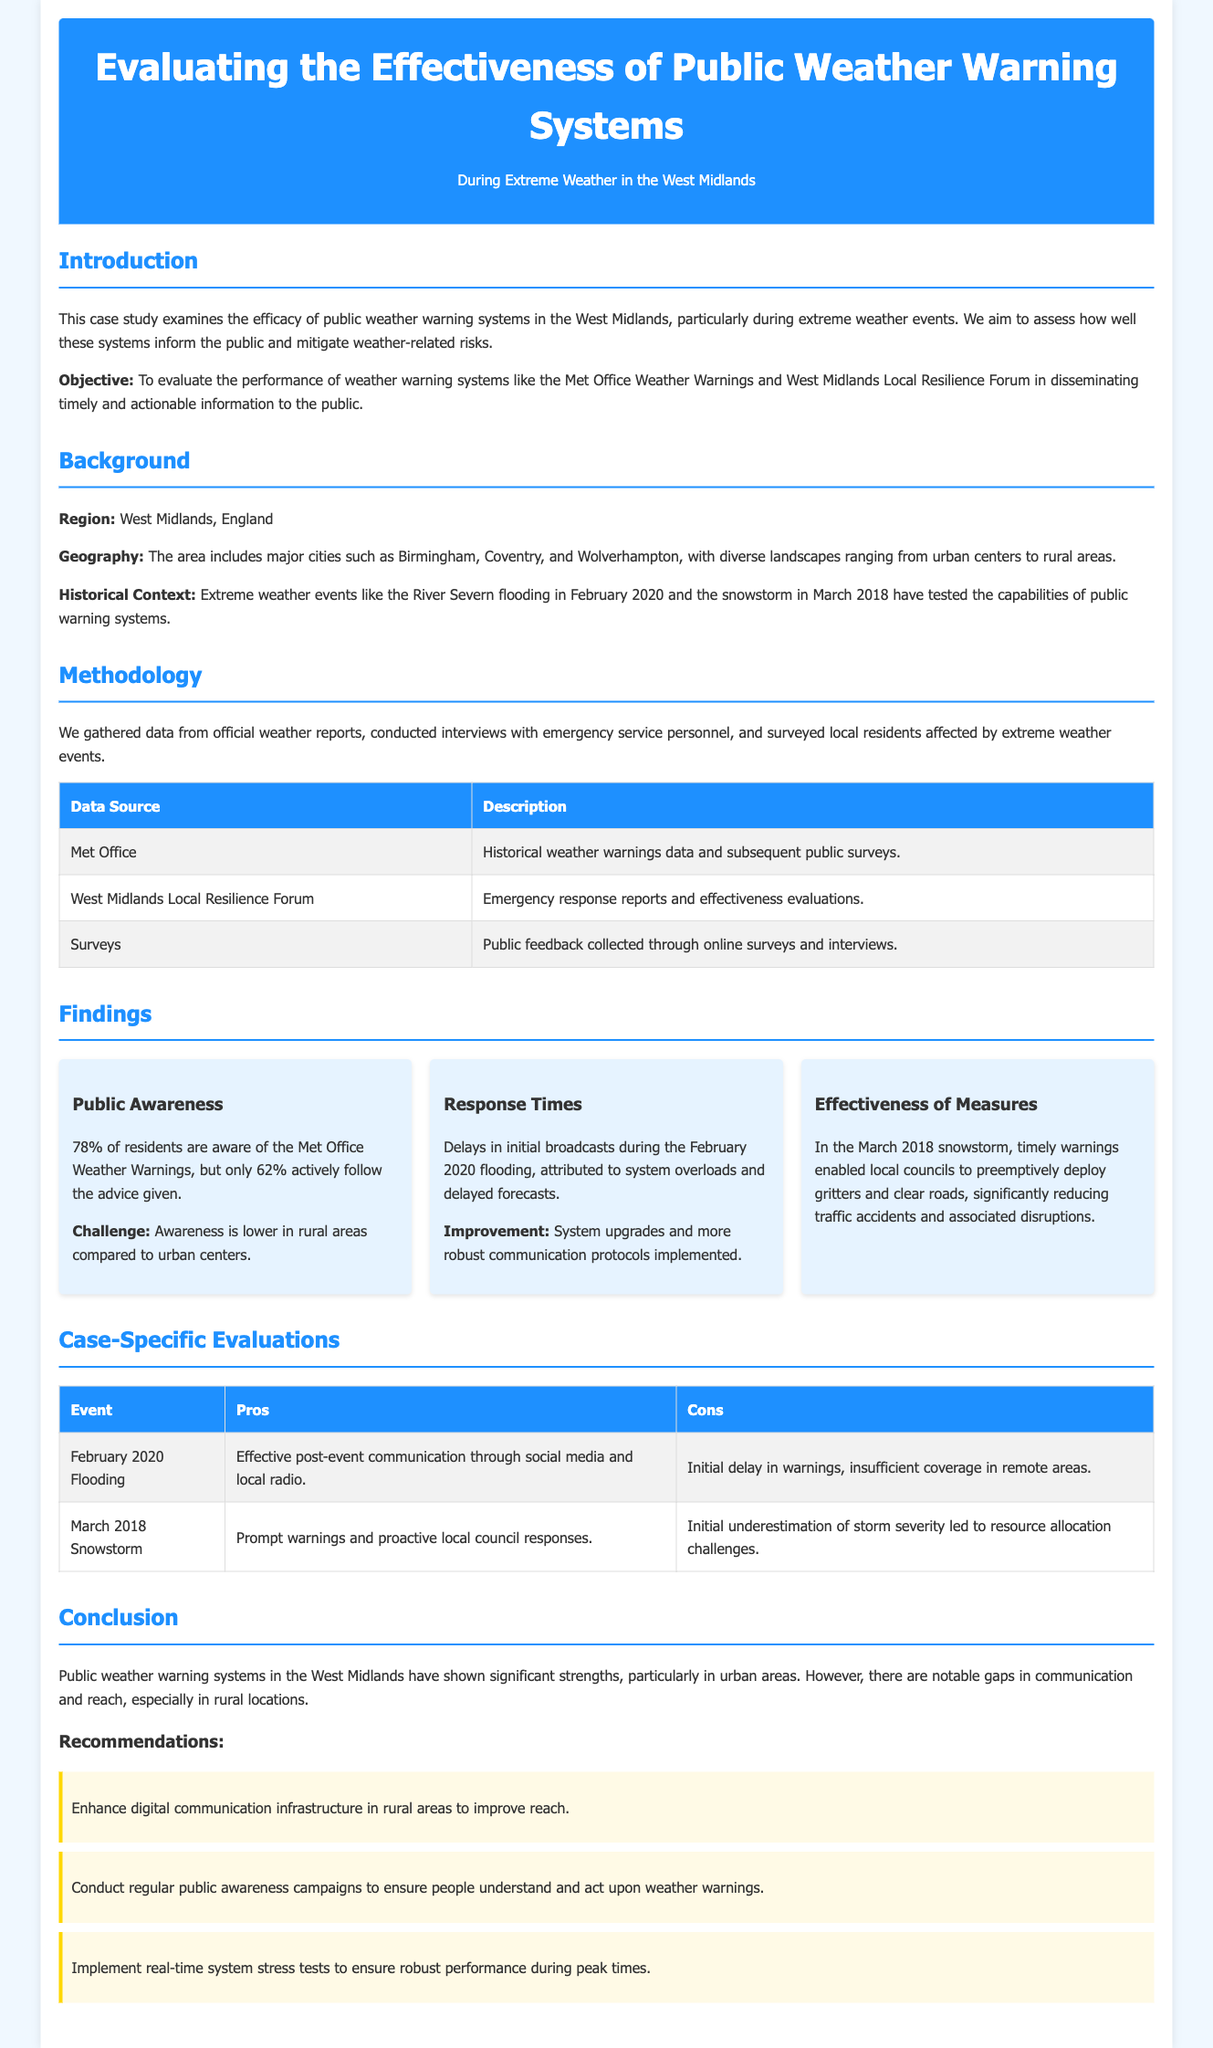What is the primary objective of the case study? The objective is to evaluate the performance of weather warning systems in disseminating timely and actionable information to the public.
Answer: To evaluate the performance of weather warning systems What percentage of residents are aware of the Met Office Weather Warnings? The document states that 78% of residents are aware of the Met Office Weather Warnings.
Answer: 78% Which extreme weather event tested public warning systems in February 2020? The River Severn flooding is mentioned as an extreme weather event in February 2020.
Answer: River Severn flooding What improvement actions were noted after the February 2020 flooding? The document mentions that system upgrades and more robust communication protocols were implemented as improvements.
Answer: System upgrades and robust communication protocols What was a major challenge noted during the March 2018 snowstorm? The challenge was initial underestimation of storm severity leading to resource allocation challenges.
Answer: Initial underestimation of storm severity How many recommendations are made in the conclusion? Three recommendations are listed in the conclusion of the document.
Answer: Three What data source includes historical weather warnings data? The 'Met Office' is identified as the data source that includes historical weather warnings data.
Answer: Met Office What was a positive aspect of the response during the February 2020 flooding? The document notes effective post-event communication through social media and local radio as a positive aspect.
Answer: Effective post-event communication 